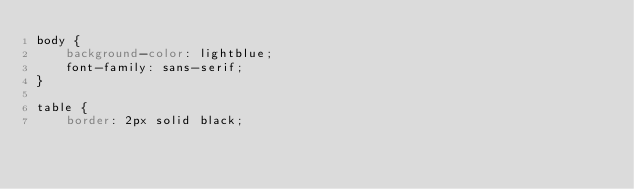Convert code to text. <code><loc_0><loc_0><loc_500><loc_500><_CSS_>body {
    background-color: lightblue;
    font-family: sans-serif;
}

table {
    border: 2px solid black;</code> 